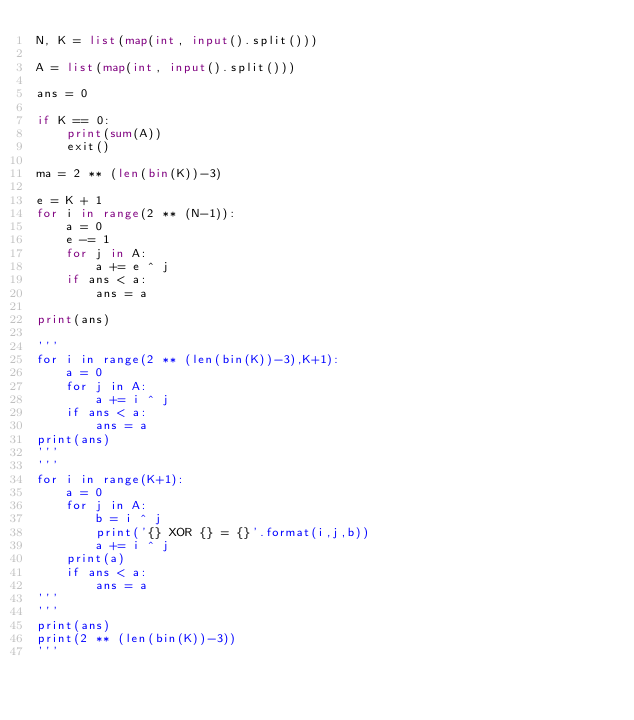<code> <loc_0><loc_0><loc_500><loc_500><_Python_>N, K = list(map(int, input().split()))

A = list(map(int, input().split()))

ans = 0

if K == 0:
    print(sum(A))
    exit()

ma = 2 ** (len(bin(K))-3)

e = K + 1
for i in range(2 ** (N-1)):
    a = 0
    e -= 1
    for j in A:
        a += e ^ j
    if ans < a:
        ans = a

print(ans)

'''
for i in range(2 ** (len(bin(K))-3),K+1):
    a = 0
    for j in A:
        a += i ^ j
    if ans < a:
        ans = a
print(ans)
'''
'''
for i in range(K+1):
    a = 0
    for j in A:
        b = i ^ j
        print('{} XOR {} = {}'.format(i,j,b))
        a += i ^ j
    print(a)
    if ans < a:
        ans = a
'''
'''
print(ans)
print(2 ** (len(bin(K))-3))
'''

</code> 